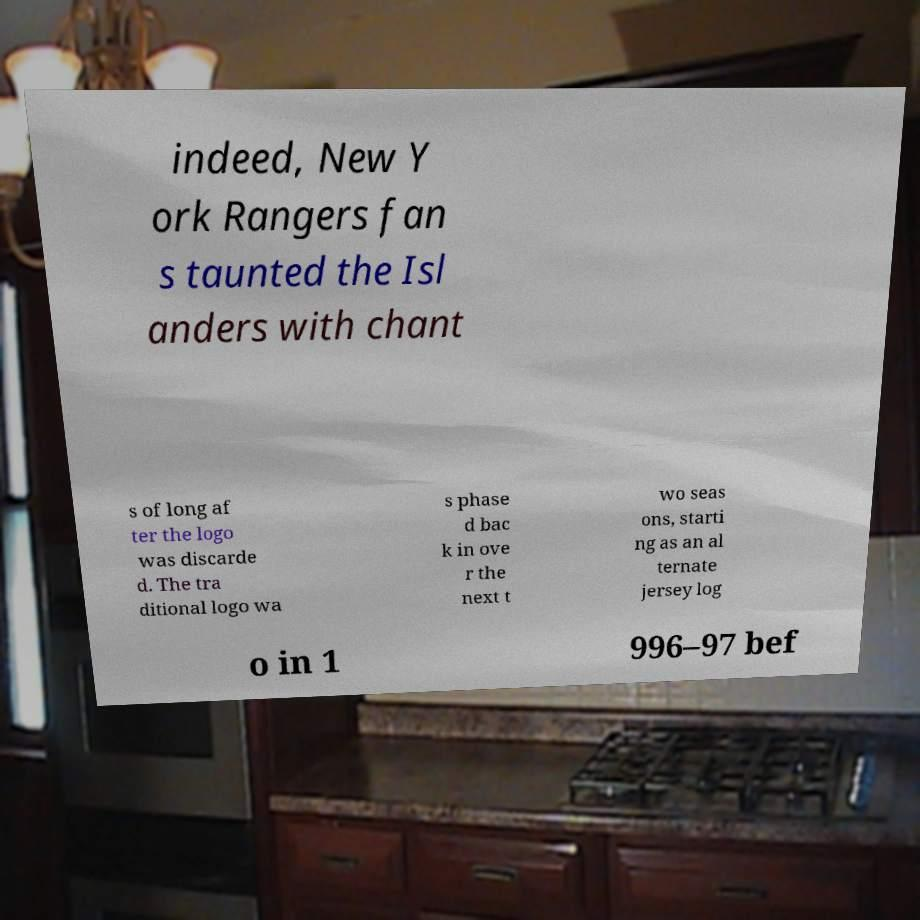There's text embedded in this image that I need extracted. Can you transcribe it verbatim? indeed, New Y ork Rangers fan s taunted the Isl anders with chant s of long af ter the logo was discarde d. The tra ditional logo wa s phase d bac k in ove r the next t wo seas ons, starti ng as an al ternate jersey log o in 1 996–97 bef 